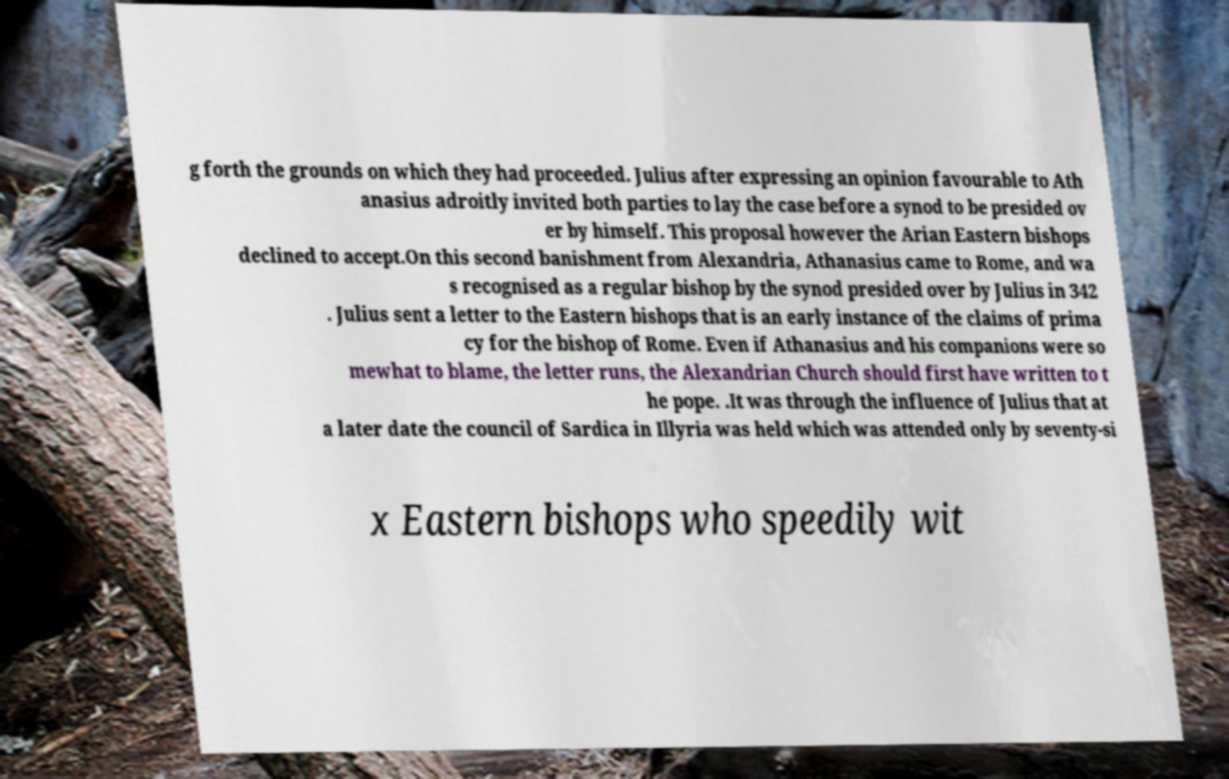Could you extract and type out the text from this image? g forth the grounds on which they had proceeded. Julius after expressing an opinion favourable to Ath anasius adroitly invited both parties to lay the case before a synod to be presided ov er by himself. This proposal however the Arian Eastern bishops declined to accept.On this second banishment from Alexandria, Athanasius came to Rome, and wa s recognised as a regular bishop by the synod presided over by Julius in 342 . Julius sent a letter to the Eastern bishops that is an early instance of the claims of prima cy for the bishop of Rome. Even if Athanasius and his companions were so mewhat to blame, the letter runs, the Alexandrian Church should first have written to t he pope. .It was through the influence of Julius that at a later date the council of Sardica in Illyria was held which was attended only by seventy-si x Eastern bishops who speedily wit 